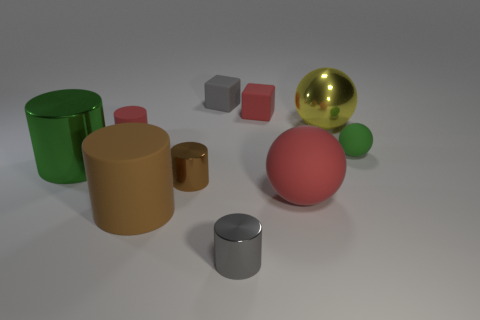What is the shape of the tiny gray thing that is made of the same material as the yellow ball?
Provide a succinct answer. Cylinder. What color is the cylinder that is both right of the brown matte cylinder and behind the small gray cylinder?
Offer a terse response. Brown. How many cylinders are either tiny metallic objects or large yellow things?
Offer a very short reply. 2. How many green rubber objects have the same size as the green ball?
Your response must be concise. 0. What number of small rubber cubes are behind the cube in front of the small gray cube?
Ensure brevity in your answer.  1. What size is the rubber thing that is both behind the small red matte cylinder and in front of the small gray rubber block?
Your answer should be very brief. Small. Is the number of large brown matte cylinders greater than the number of yellow cylinders?
Make the answer very short. Yes. Are there any matte blocks of the same color as the big shiny sphere?
Keep it short and to the point. No. Does the gray object right of the gray matte thing have the same size as the red cylinder?
Your response must be concise. Yes. Is the number of large green rubber objects less than the number of brown metallic cylinders?
Offer a terse response. Yes. 